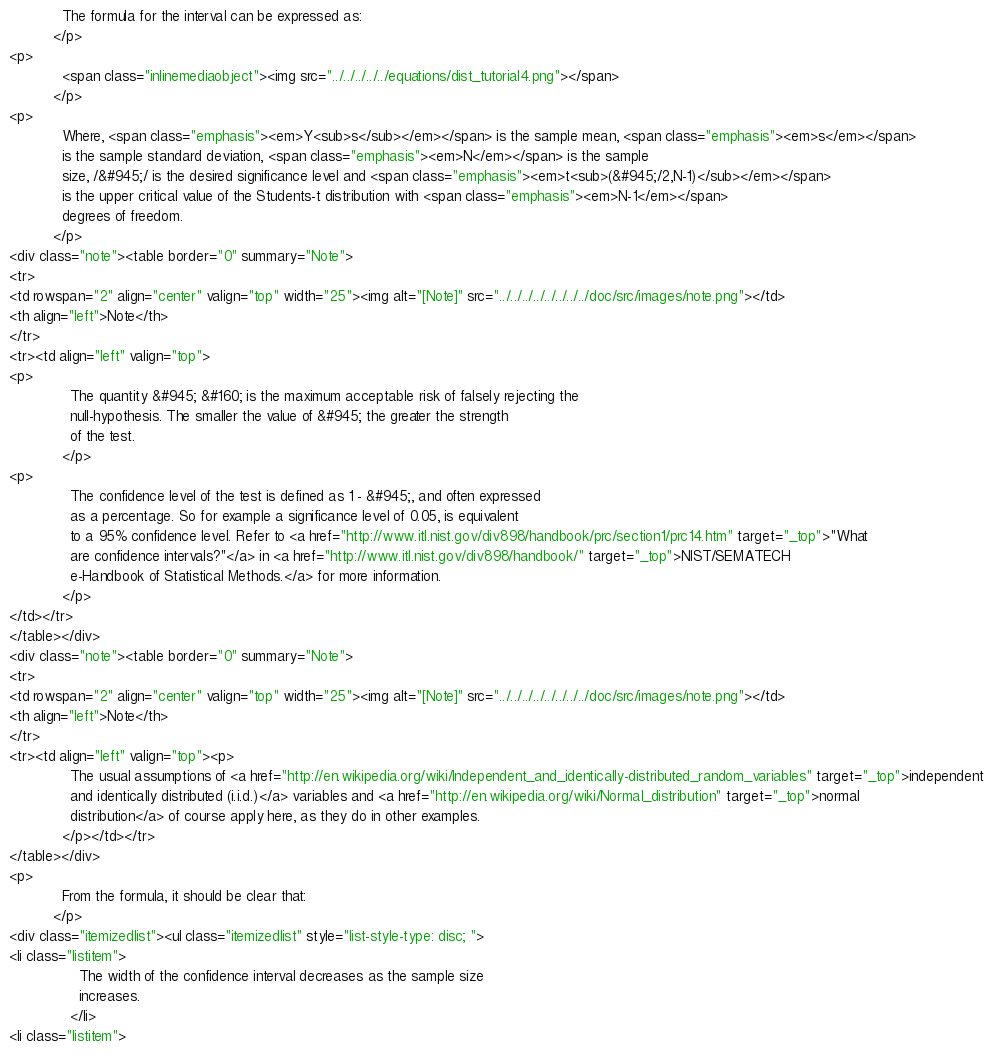Convert code to text. <code><loc_0><loc_0><loc_500><loc_500><_HTML_>            The formula for the interval can be expressed as:
          </p>
<p>
            <span class="inlinemediaobject"><img src="../../../../../equations/dist_tutorial4.png"></span>
          </p>
<p>
            Where, <span class="emphasis"><em>Y<sub>s</sub></em></span> is the sample mean, <span class="emphasis"><em>s</em></span>
            is the sample standard deviation, <span class="emphasis"><em>N</em></span> is the sample
            size, /&#945;/ is the desired significance level and <span class="emphasis"><em>t<sub>(&#945;/2,N-1)</sub></em></span>
            is the upper critical value of the Students-t distribution with <span class="emphasis"><em>N-1</em></span>
            degrees of freedom.
          </p>
<div class="note"><table border="0" summary="Note">
<tr>
<td rowspan="2" align="center" valign="top" width="25"><img alt="[Note]" src="../../../../../../../../doc/src/images/note.png"></td>
<th align="left">Note</th>
</tr>
<tr><td align="left" valign="top">
<p>
              The quantity &#945; &#160; is the maximum acceptable risk of falsely rejecting the
              null-hypothesis. The smaller the value of &#945; the greater the strength
              of the test.
            </p>
<p>
              The confidence level of the test is defined as 1 - &#945;, and often expressed
              as a percentage. So for example a significance level of 0.05, is equivalent
              to a 95% confidence level. Refer to <a href="http://www.itl.nist.gov/div898/handbook/prc/section1/prc14.htm" target="_top">"What
              are confidence intervals?"</a> in <a href="http://www.itl.nist.gov/div898/handbook/" target="_top">NIST/SEMATECH
              e-Handbook of Statistical Methods.</a> for more information.
            </p>
</td></tr>
</table></div>
<div class="note"><table border="0" summary="Note">
<tr>
<td rowspan="2" align="center" valign="top" width="25"><img alt="[Note]" src="../../../../../../../../doc/src/images/note.png"></td>
<th align="left">Note</th>
</tr>
<tr><td align="left" valign="top"><p>
              The usual assumptions of <a href="http://en.wikipedia.org/wiki/Independent_and_identically-distributed_random_variables" target="_top">independent
              and identically distributed (i.i.d.)</a> variables and <a href="http://en.wikipedia.org/wiki/Normal_distribution" target="_top">normal
              distribution</a> of course apply here, as they do in other examples.
            </p></td></tr>
</table></div>
<p>
            From the formula, it should be clear that:
          </p>
<div class="itemizedlist"><ul class="itemizedlist" style="list-style-type: disc; ">
<li class="listitem">
                The width of the confidence interval decreases as the sample size
                increases.
              </li>
<li class="listitem"></code> 